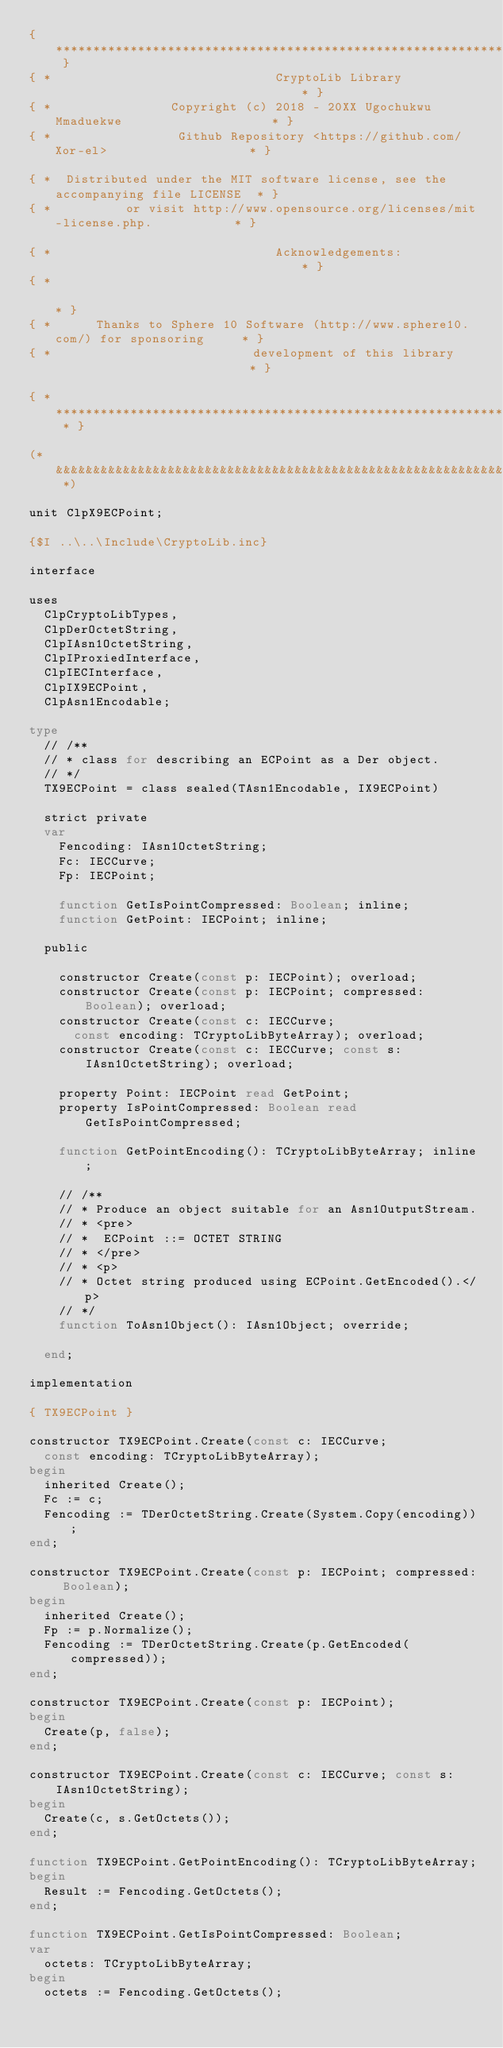<code> <loc_0><loc_0><loc_500><loc_500><_Pascal_>{ *********************************************************************************** }
{ *                              CryptoLib Library                                  * }
{ *                Copyright (c) 2018 - 20XX Ugochukwu Mmaduekwe                    * }
{ *                 Github Repository <https://github.com/Xor-el>                   * }

{ *  Distributed under the MIT software license, see the accompanying file LICENSE  * }
{ *          or visit http://www.opensource.org/licenses/mit-license.php.           * }

{ *                              Acknowledgements:                                  * }
{ *                                                                                 * }
{ *      Thanks to Sphere 10 Software (http://www.sphere10.com/) for sponsoring     * }
{ *                           development of this library                           * }

{ * ******************************************************************************* * }

(* &&&&&&&&&&&&&&&&&&&&&&&&&&&&&&&&&&&&&&&&&&&&&&&&&&&&&&&&&&&&&&&&&&&&&&&&&&&&&&&&& *)

unit ClpX9ECPoint;

{$I ..\..\Include\CryptoLib.inc}

interface

uses
  ClpCryptoLibTypes,
  ClpDerOctetString,
  ClpIAsn1OctetString,
  ClpIProxiedInterface,
  ClpIECInterface,
  ClpIX9ECPoint,
  ClpAsn1Encodable;

type
  // /**
  // * class for describing an ECPoint as a Der object.
  // */
  TX9ECPoint = class sealed(TAsn1Encodable, IX9ECPoint)

  strict private
  var
    Fencoding: IAsn1OctetString;
    Fc: IECCurve;
    Fp: IECPoint;

    function GetIsPointCompressed: Boolean; inline;
    function GetPoint: IECPoint; inline;

  public

    constructor Create(const p: IECPoint); overload;
    constructor Create(const p: IECPoint; compressed: Boolean); overload;
    constructor Create(const c: IECCurve;
      const encoding: TCryptoLibByteArray); overload;
    constructor Create(const c: IECCurve; const s: IAsn1OctetString); overload;

    property Point: IECPoint read GetPoint;
    property IsPointCompressed: Boolean read GetIsPointCompressed;

    function GetPointEncoding(): TCryptoLibByteArray; inline;

    // /**
    // * Produce an object suitable for an Asn1OutputStream.
    // * <pre>
    // *  ECPoint ::= OCTET STRING
    // * </pre>
    // * <p>
    // * Octet string produced using ECPoint.GetEncoded().</p>
    // */
    function ToAsn1Object(): IAsn1Object; override;

  end;

implementation

{ TX9ECPoint }

constructor TX9ECPoint.Create(const c: IECCurve;
  const encoding: TCryptoLibByteArray);
begin
  inherited Create();
  Fc := c;
  Fencoding := TDerOctetString.Create(System.Copy(encoding));
end;

constructor TX9ECPoint.Create(const p: IECPoint; compressed: Boolean);
begin
  inherited Create();
  Fp := p.Normalize();
  Fencoding := TDerOctetString.Create(p.GetEncoded(compressed));
end;

constructor TX9ECPoint.Create(const p: IECPoint);
begin
  Create(p, false);
end;

constructor TX9ECPoint.Create(const c: IECCurve; const s: IAsn1OctetString);
begin
  Create(c, s.GetOctets());
end;

function TX9ECPoint.GetPointEncoding(): TCryptoLibByteArray;
begin
  Result := Fencoding.GetOctets();
end;

function TX9ECPoint.GetIsPointCompressed: Boolean;
var
  octets: TCryptoLibByteArray;
begin
  octets := Fencoding.GetOctets();</code> 